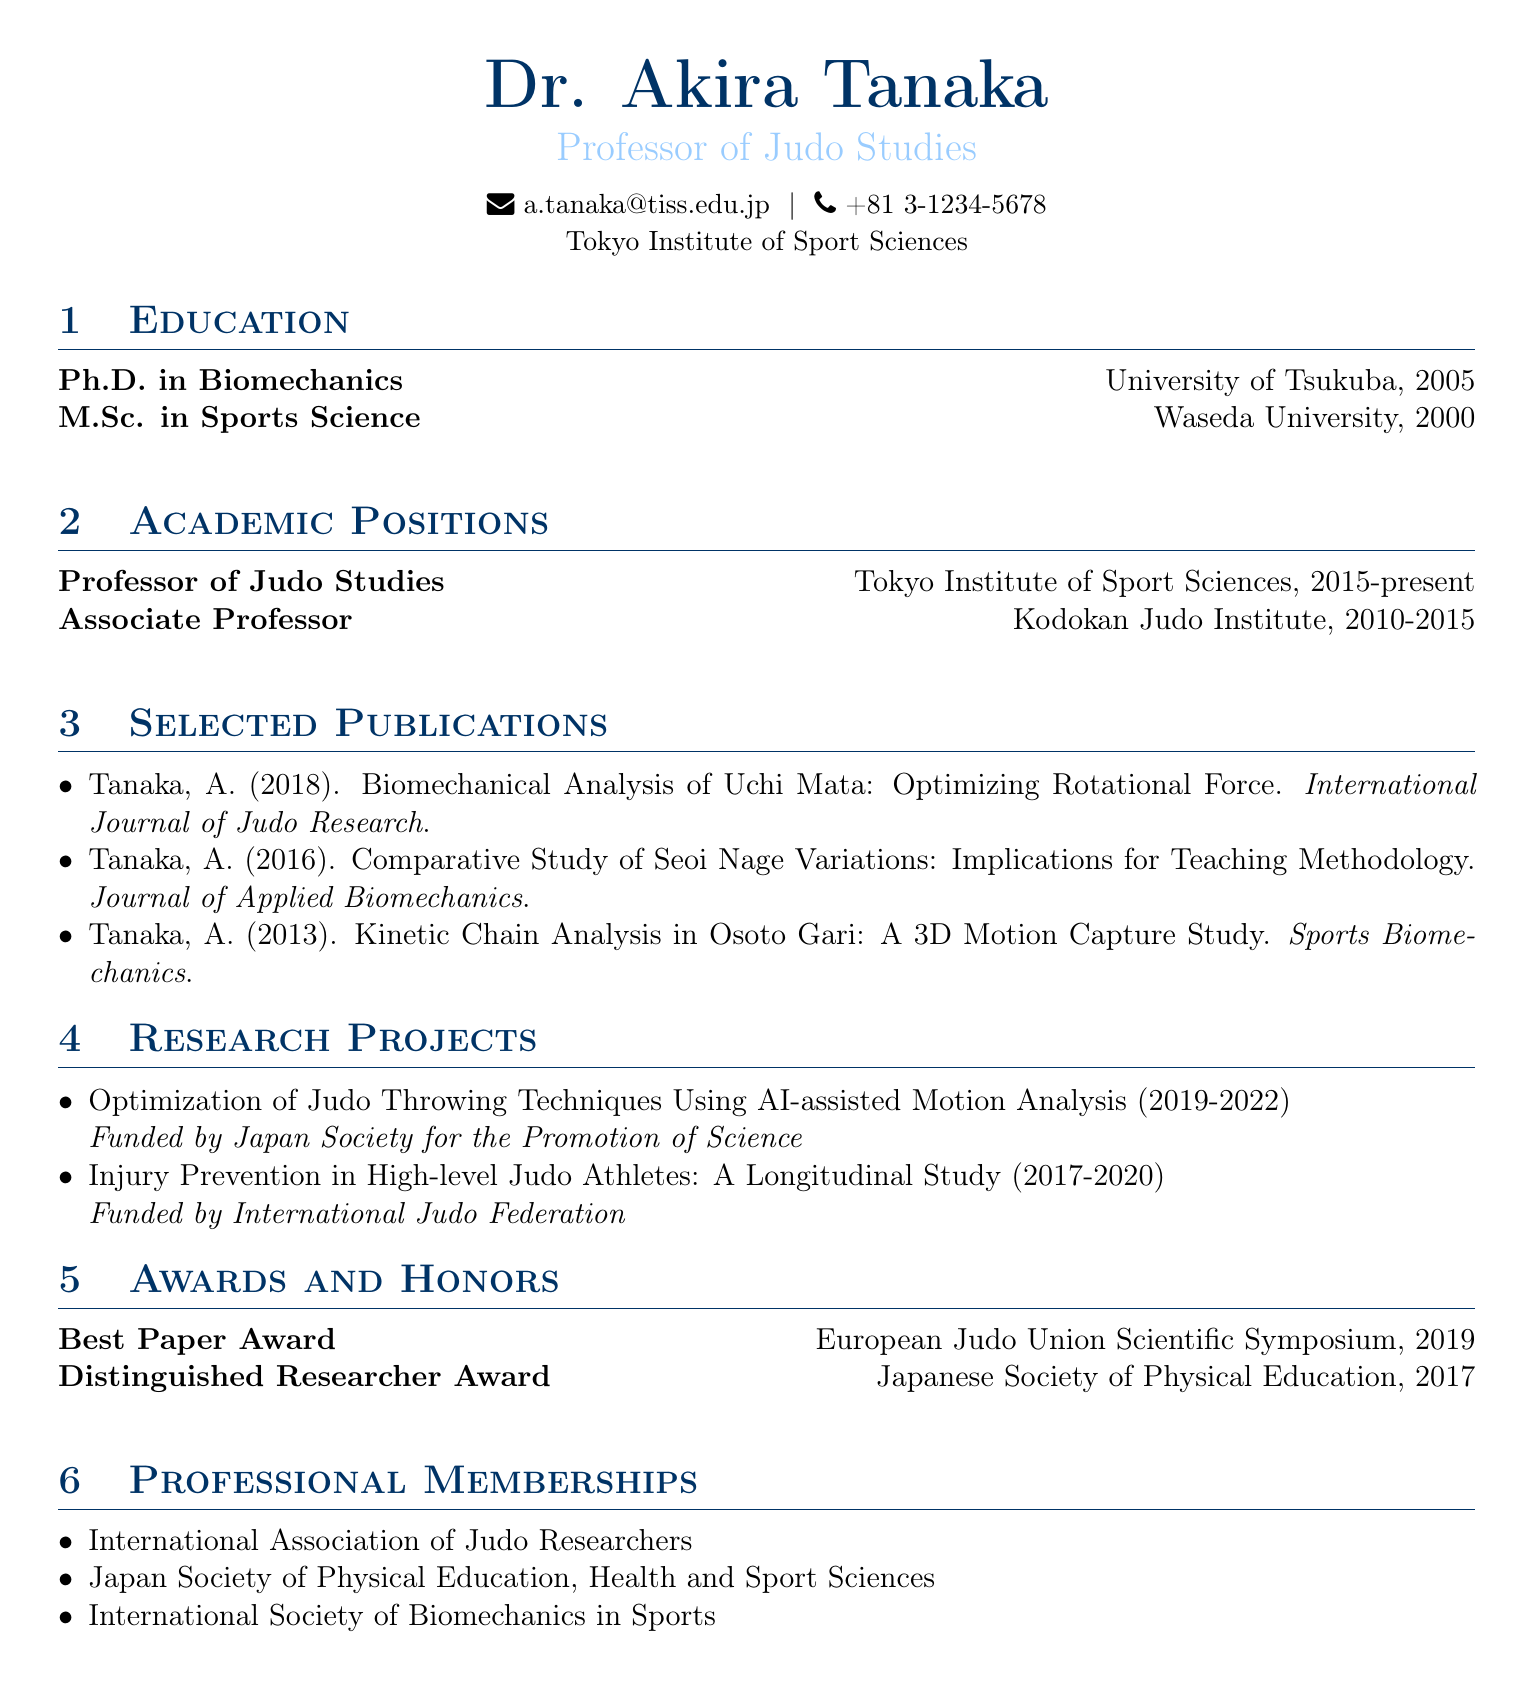what is Dr. Akira Tanaka's email address? The email address of Dr. Akira Tanaka is mentioned in the personal information section of the CV.
Answer: a.tanaka@tiss.edu.jp what is the title of the publication from 2018? The CV lists the publications, including the year, title, and journal. The 2018 publication is specifically titled "Biomechanical Analysis of Uchi Mata: Optimizing Rotational Force".
Answer: Biomechanical Analysis of Uchi Mata: Optimizing Rotational Force which institution is Dr. Tanaka affiliated with? Dr. Tanaka's current institutional affiliation is stated in the personal information section.
Answer: Tokyo Institute of Sport Sciences how many years did Dr. Tanaka serve at the Kodokan Judo Institute? The period of service at the Kodokan Judo Institute is specified in the academic positions section of the CV. It is from 2010 to 2015, which totals five years.
Answer: 5 years which award did Dr. Tanaka receive in 2019? The awards section includes titles and years, indicating the award received in 2019.
Answer: Best Paper Award what is the focus of Dr. Tanaka's research projects? The titles of the listed research projects reveal the areas of focus, including optimization of throwing techniques and injury prevention.
Answer: Judo throwing techniques and injury prevention which two universities did Dr. Tanaka attend for his higher education? The education section presents information regarding the institutions from which Dr. Tanaka obtained his degrees.
Answer: University of Tsukuba, Waseda University what is the range of years for the first research project listed? The years for each research project are provided, with the first project spanning from 2019 to 2022.
Answer: 2019-2022 